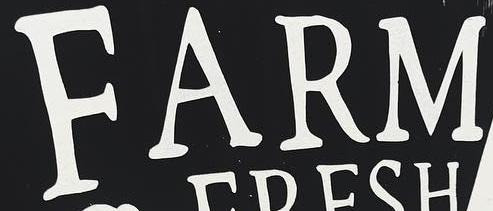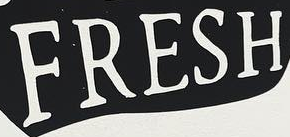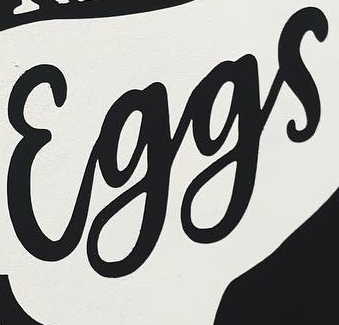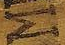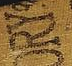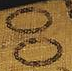What text appears in these images from left to right, separated by a semicolon? FARM; FRESH; Eggs; M; ORY; OO 